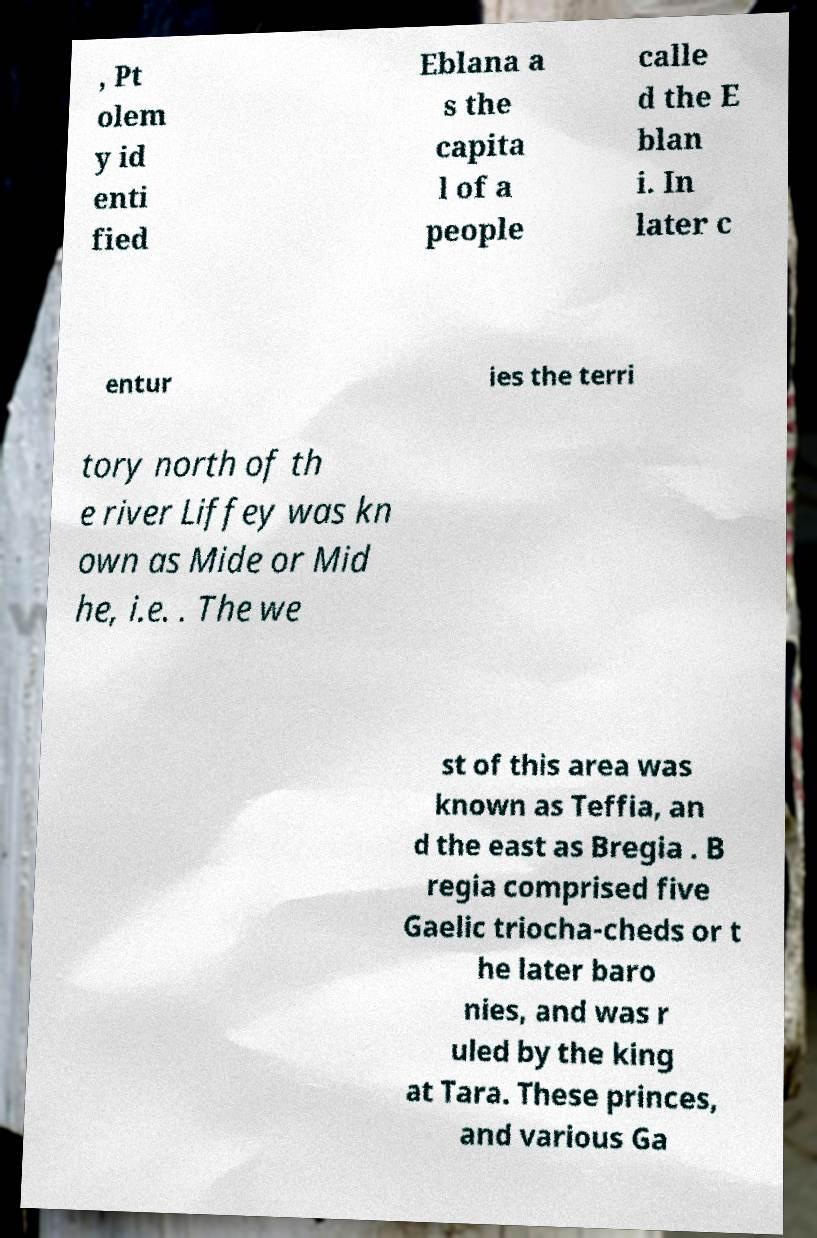Could you extract and type out the text from this image? , Pt olem y id enti fied Eblana a s the capita l of a people calle d the E blan i. In later c entur ies the terri tory north of th e river Liffey was kn own as Mide or Mid he, i.e. . The we st of this area was known as Teffia, an d the east as Bregia . B regia comprised five Gaelic triocha-cheds or t he later baro nies, and was r uled by the king at Tara. These princes, and various Ga 